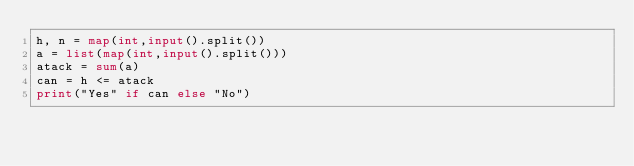Convert code to text. <code><loc_0><loc_0><loc_500><loc_500><_Python_>h, n = map(int,input().split())
a = list(map(int,input().split()))
atack = sum(a)
can = h <= atack
print("Yes" if can else "No")</code> 